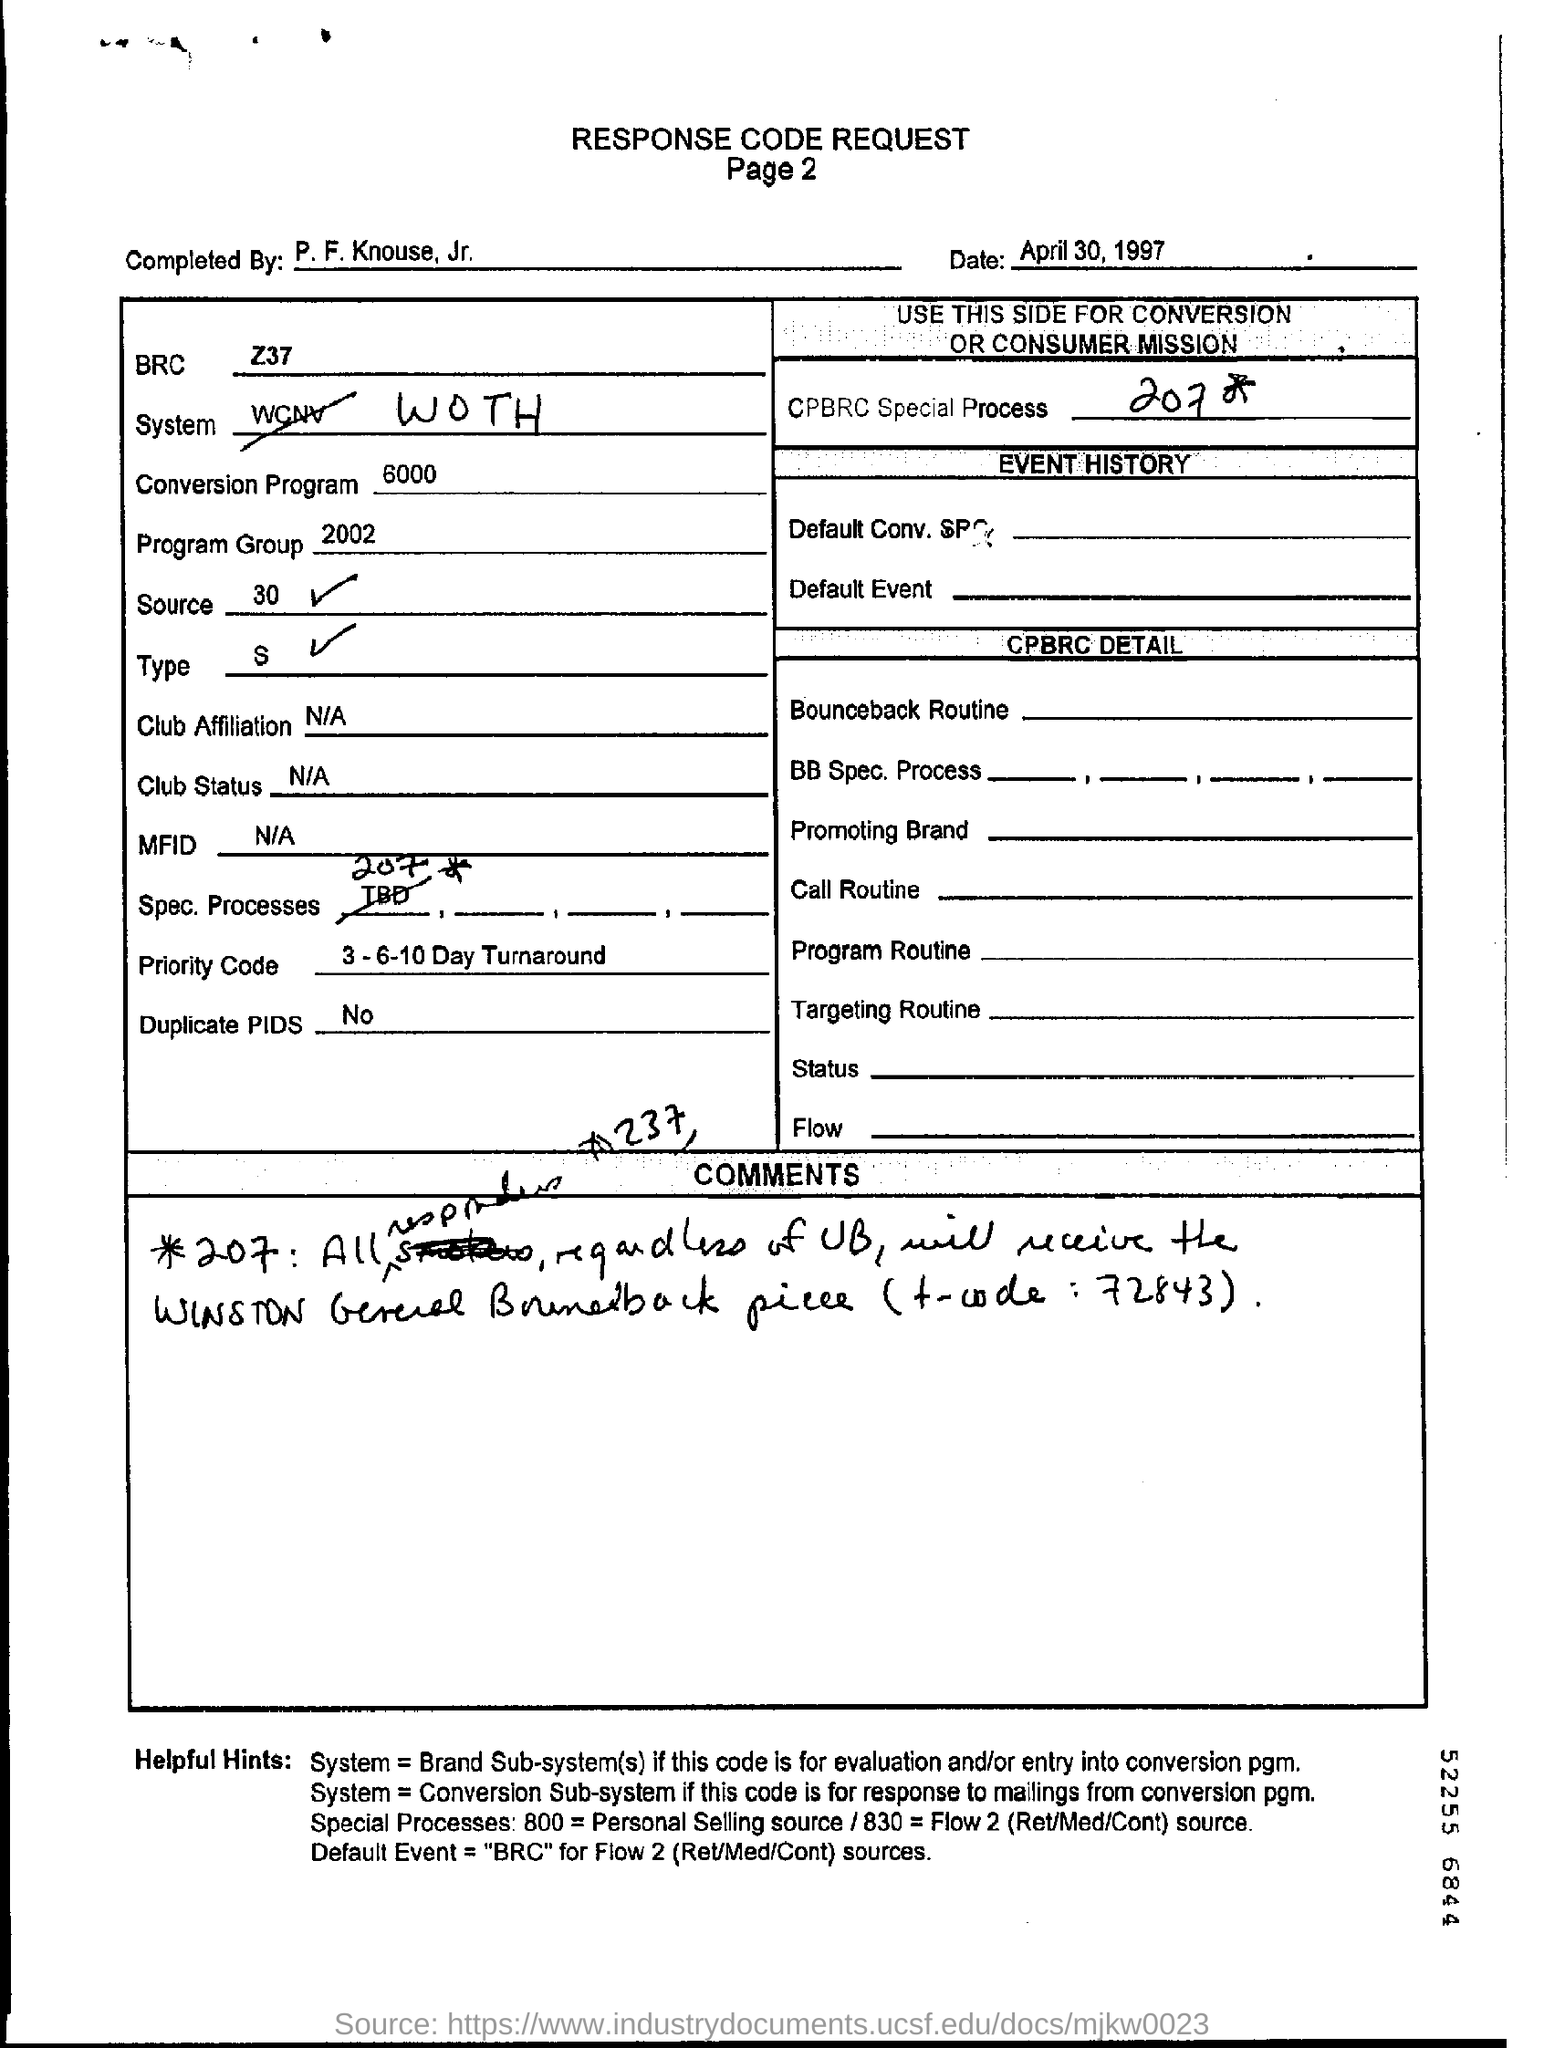Identify some key points in this picture. The BRC mentions [specific subject]. The conversion program mentions 6000... The source mentions 30 as a specific number. The Criminal Procedure and Review Commission (CPBRC) has a special process for handling cases that involve complex or sensitive issues. This process is aimed at ensuring that the cases are handled in a fair and transparent manner. However, the specific details of this process are not mentioned in the provided text. The number that belongs to the program group is 2002. 